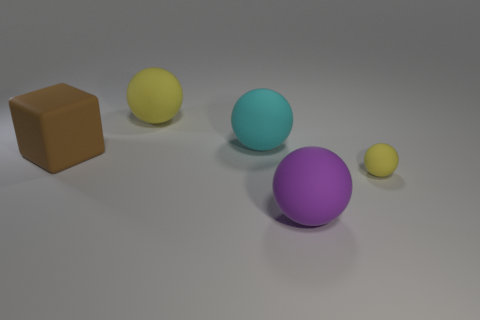Is the color of the cube behind the purple rubber object the same as the tiny ball?
Your answer should be compact. No. What number of purple objects have the same shape as the big cyan thing?
Offer a terse response. 1. Is the number of big yellow things in front of the small yellow thing the same as the number of matte objects?
Your answer should be compact. No. There is a cube that is the same size as the cyan rubber sphere; what is its color?
Offer a very short reply. Brown. Is there a small gray thing of the same shape as the big brown object?
Your response must be concise. No. What material is the yellow object behind the matte object that is to the left of the large ball that is on the left side of the large cyan object?
Make the answer very short. Rubber. The tiny rubber thing has what color?
Give a very brief answer. Yellow. What number of matte things are big red spheres or purple balls?
Make the answer very short. 1. Are there any other things that are the same material as the large cyan object?
Make the answer very short. Yes. What is the size of the yellow matte thing in front of the large matte thing to the left of the rubber object that is behind the large cyan rubber sphere?
Your answer should be very brief. Small. 